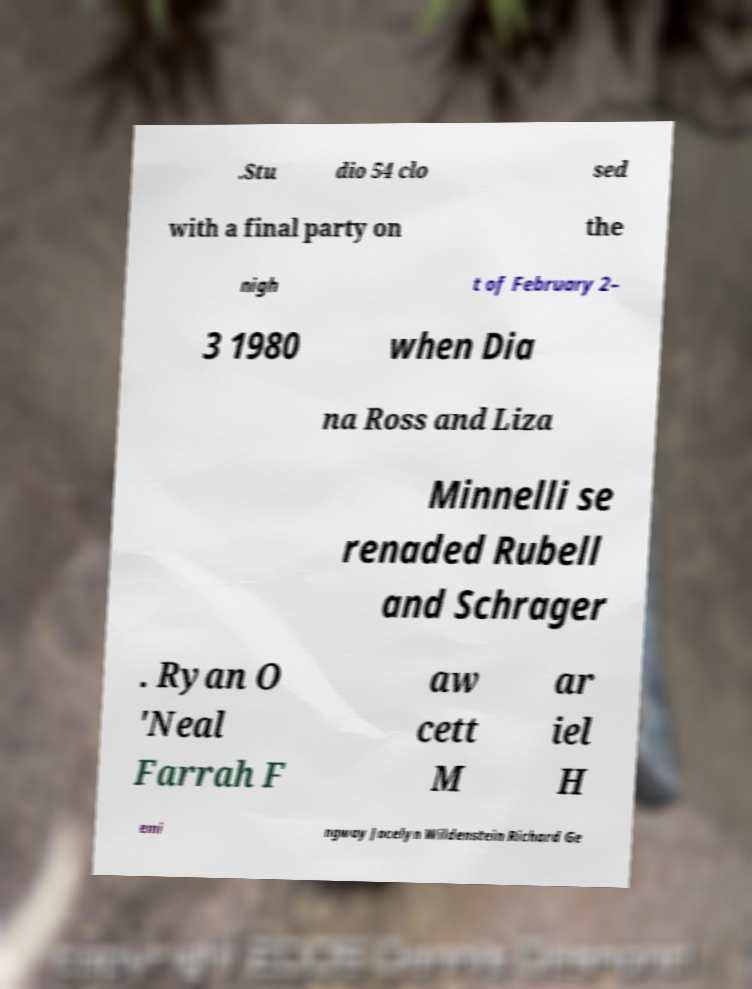I need the written content from this picture converted into text. Can you do that? .Stu dio 54 clo sed with a final party on the nigh t of February 2– 3 1980 when Dia na Ross and Liza Minnelli se renaded Rubell and Schrager . Ryan O 'Neal Farrah F aw cett M ar iel H emi ngway Jocelyn Wildenstein Richard Ge 